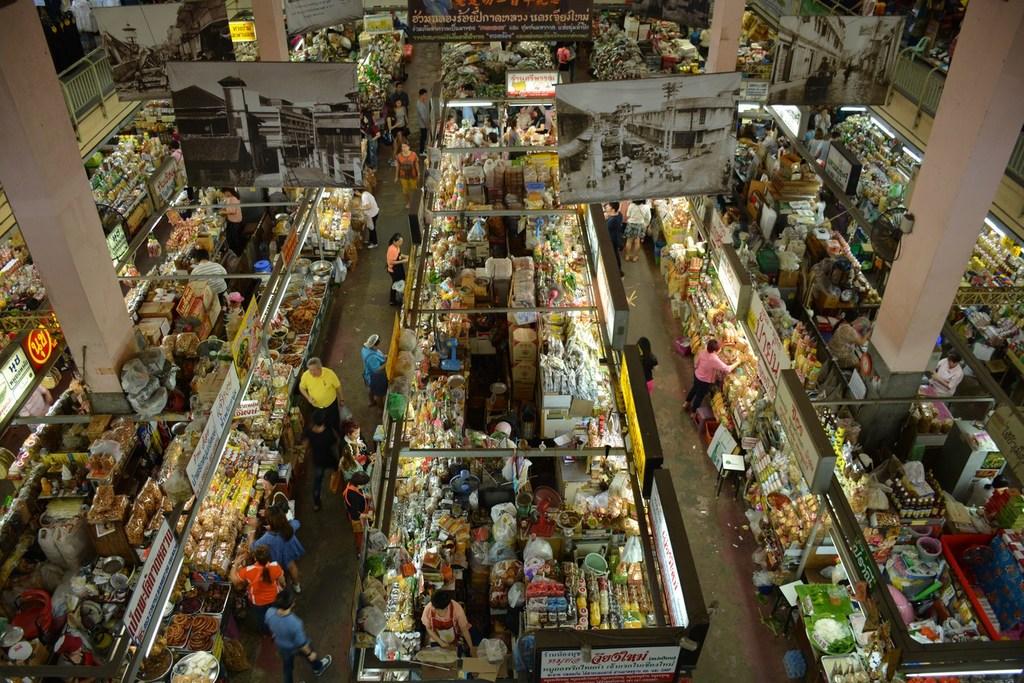Is the sign in the store written in english?
Make the answer very short. No. 